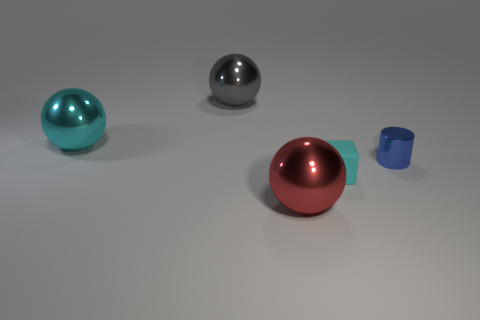Is there any other thing that is made of the same material as the tiny block?
Your answer should be very brief. No. How big is the shiny object that is both behind the large red ball and in front of the big cyan thing?
Keep it short and to the point. Small. What number of objects are either large red objects or large things in front of the large cyan object?
Offer a terse response. 1. What is the shape of the large gray object?
Make the answer very short. Sphere. There is a cyan thing behind the small object behind the cyan matte block; what is its shape?
Offer a terse response. Sphere. There is a tiny object in front of the tiny blue object; does it have the same color as the metal object that is left of the gray metal thing?
Your answer should be compact. Yes. Are there more metallic objects to the left of the small blue thing than metallic objects that are behind the large red object?
Offer a very short reply. No. Is there any other thing that is the same shape as the small cyan thing?
Keep it short and to the point. No. There is a large red metal thing; is it the same shape as the tiny thing that is to the left of the tiny blue thing?
Ensure brevity in your answer.  No. How many other objects are the same material as the small cyan block?
Provide a succinct answer. 0. 